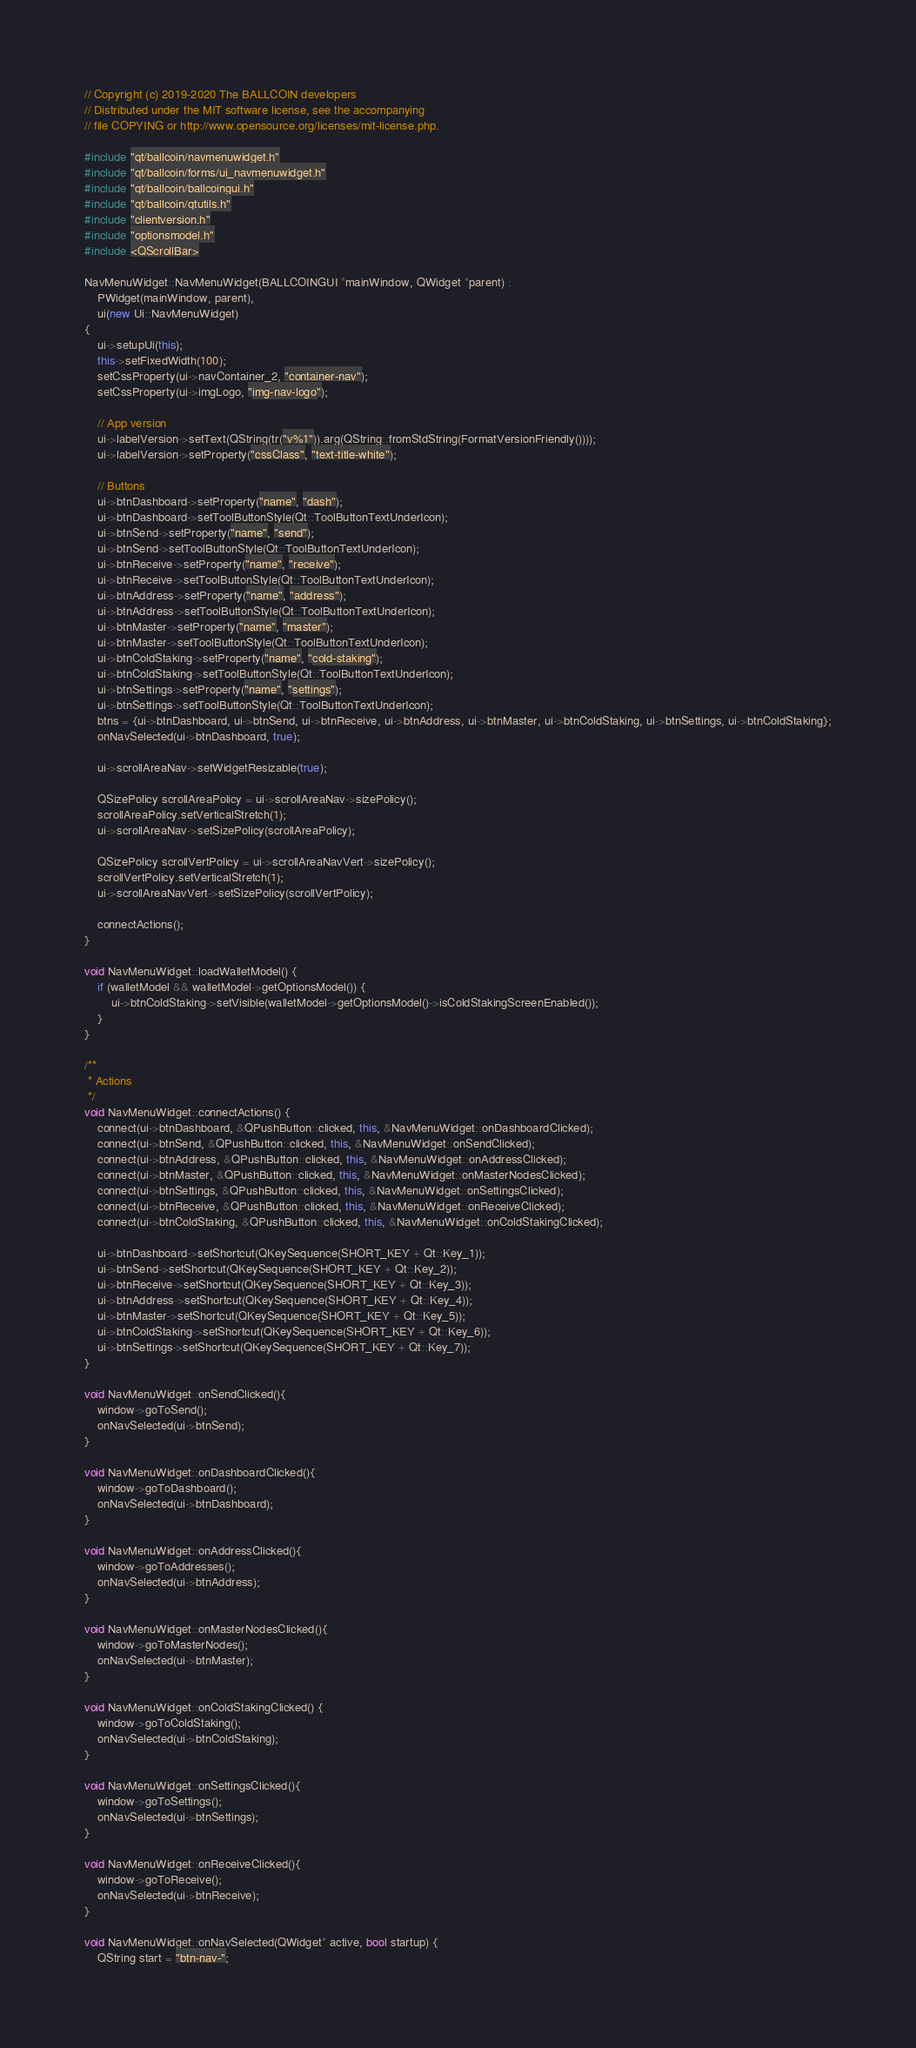Convert code to text. <code><loc_0><loc_0><loc_500><loc_500><_C++_>// Copyright (c) 2019-2020 The BALLCOIN developers
// Distributed under the MIT software license, see the accompanying
// file COPYING or http://www.opensource.org/licenses/mit-license.php.

#include "qt/ballcoin/navmenuwidget.h"
#include "qt/ballcoin/forms/ui_navmenuwidget.h"
#include "qt/ballcoin/ballcoingui.h"
#include "qt/ballcoin/qtutils.h"
#include "clientversion.h"
#include "optionsmodel.h"
#include <QScrollBar>

NavMenuWidget::NavMenuWidget(BALLCOINGUI *mainWindow, QWidget *parent) :
    PWidget(mainWindow, parent),
    ui(new Ui::NavMenuWidget)
{
    ui->setupUi(this);
    this->setFixedWidth(100);
    setCssProperty(ui->navContainer_2, "container-nav");
    setCssProperty(ui->imgLogo, "img-nav-logo");

    // App version
    ui->labelVersion->setText(QString(tr("v%1")).arg(QString::fromStdString(FormatVersionFriendly())));
    ui->labelVersion->setProperty("cssClass", "text-title-white");

    // Buttons
    ui->btnDashboard->setProperty("name", "dash");
    ui->btnDashboard->setToolButtonStyle(Qt::ToolButtonTextUnderIcon);
    ui->btnSend->setProperty("name", "send");
    ui->btnSend->setToolButtonStyle(Qt::ToolButtonTextUnderIcon);
    ui->btnReceive->setProperty("name", "receive");
    ui->btnReceive->setToolButtonStyle(Qt::ToolButtonTextUnderIcon);
    ui->btnAddress->setProperty("name", "address");
    ui->btnAddress->setToolButtonStyle(Qt::ToolButtonTextUnderIcon);
    ui->btnMaster->setProperty("name", "master");
    ui->btnMaster->setToolButtonStyle(Qt::ToolButtonTextUnderIcon);
    ui->btnColdStaking->setProperty("name", "cold-staking");
    ui->btnColdStaking->setToolButtonStyle(Qt::ToolButtonTextUnderIcon);
    ui->btnSettings->setProperty("name", "settings");
    ui->btnSettings->setToolButtonStyle(Qt::ToolButtonTextUnderIcon);
    btns = {ui->btnDashboard, ui->btnSend, ui->btnReceive, ui->btnAddress, ui->btnMaster, ui->btnColdStaking, ui->btnSettings, ui->btnColdStaking};
    onNavSelected(ui->btnDashboard, true);

    ui->scrollAreaNav->setWidgetResizable(true);

    QSizePolicy scrollAreaPolicy = ui->scrollAreaNav->sizePolicy();
    scrollAreaPolicy.setVerticalStretch(1);
    ui->scrollAreaNav->setSizePolicy(scrollAreaPolicy);

    QSizePolicy scrollVertPolicy = ui->scrollAreaNavVert->sizePolicy();
    scrollVertPolicy.setVerticalStretch(1);
    ui->scrollAreaNavVert->setSizePolicy(scrollVertPolicy);

    connectActions();
}

void NavMenuWidget::loadWalletModel() {
    if (walletModel && walletModel->getOptionsModel()) {
        ui->btnColdStaking->setVisible(walletModel->getOptionsModel()->isColdStakingScreenEnabled());
    }
}

/**
 * Actions
 */
void NavMenuWidget::connectActions() {
    connect(ui->btnDashboard, &QPushButton::clicked, this, &NavMenuWidget::onDashboardClicked);
    connect(ui->btnSend, &QPushButton::clicked, this, &NavMenuWidget::onSendClicked);
    connect(ui->btnAddress, &QPushButton::clicked, this, &NavMenuWidget::onAddressClicked);
    connect(ui->btnMaster, &QPushButton::clicked, this, &NavMenuWidget::onMasterNodesClicked);
    connect(ui->btnSettings, &QPushButton::clicked, this, &NavMenuWidget::onSettingsClicked);
    connect(ui->btnReceive, &QPushButton::clicked, this, &NavMenuWidget::onReceiveClicked);
    connect(ui->btnColdStaking, &QPushButton::clicked, this, &NavMenuWidget::onColdStakingClicked);

    ui->btnDashboard->setShortcut(QKeySequence(SHORT_KEY + Qt::Key_1));
    ui->btnSend->setShortcut(QKeySequence(SHORT_KEY + Qt::Key_2));
    ui->btnReceive->setShortcut(QKeySequence(SHORT_KEY + Qt::Key_3));
    ui->btnAddress->setShortcut(QKeySequence(SHORT_KEY + Qt::Key_4));
    ui->btnMaster->setShortcut(QKeySequence(SHORT_KEY + Qt::Key_5));
    ui->btnColdStaking->setShortcut(QKeySequence(SHORT_KEY + Qt::Key_6));
    ui->btnSettings->setShortcut(QKeySequence(SHORT_KEY + Qt::Key_7));
}

void NavMenuWidget::onSendClicked(){
    window->goToSend();
    onNavSelected(ui->btnSend);
}

void NavMenuWidget::onDashboardClicked(){
    window->goToDashboard();
    onNavSelected(ui->btnDashboard);
}

void NavMenuWidget::onAddressClicked(){
    window->goToAddresses();
    onNavSelected(ui->btnAddress);
}

void NavMenuWidget::onMasterNodesClicked(){
    window->goToMasterNodes();
    onNavSelected(ui->btnMaster);
}

void NavMenuWidget::onColdStakingClicked() {
    window->goToColdStaking();
    onNavSelected(ui->btnColdStaking);
}

void NavMenuWidget::onSettingsClicked(){
    window->goToSettings();
    onNavSelected(ui->btnSettings);
}

void NavMenuWidget::onReceiveClicked(){
    window->goToReceive();
    onNavSelected(ui->btnReceive);
}

void NavMenuWidget::onNavSelected(QWidget* active, bool startup) {
    QString start = "btn-nav-";</code> 